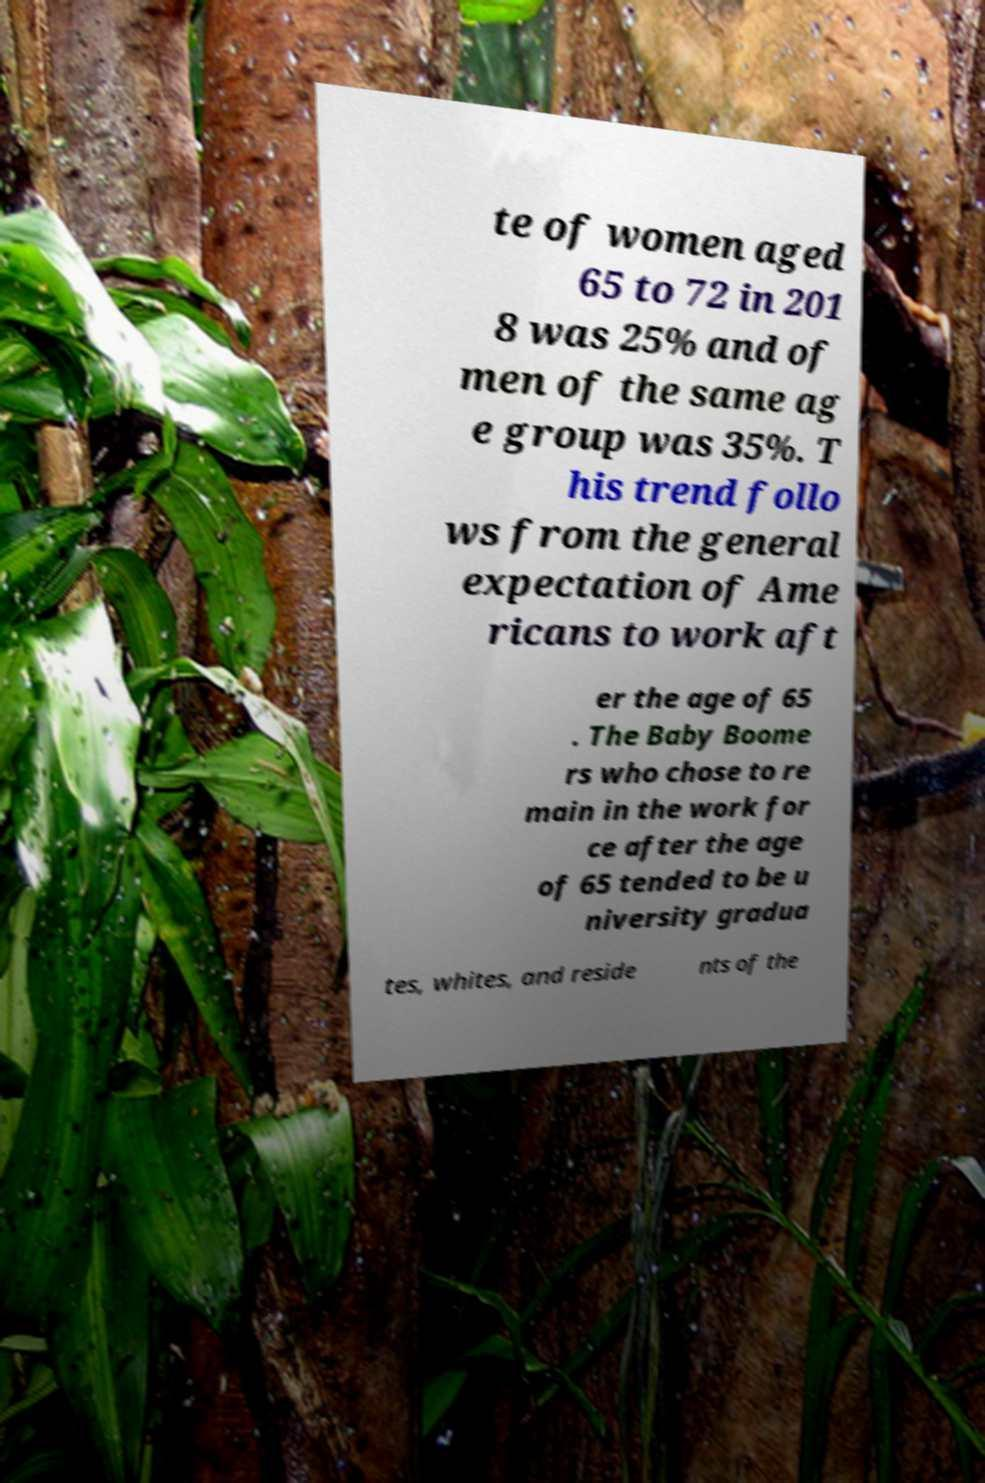Could you extract and type out the text from this image? te of women aged 65 to 72 in 201 8 was 25% and of men of the same ag e group was 35%. T his trend follo ws from the general expectation of Ame ricans to work aft er the age of 65 . The Baby Boome rs who chose to re main in the work for ce after the age of 65 tended to be u niversity gradua tes, whites, and reside nts of the 